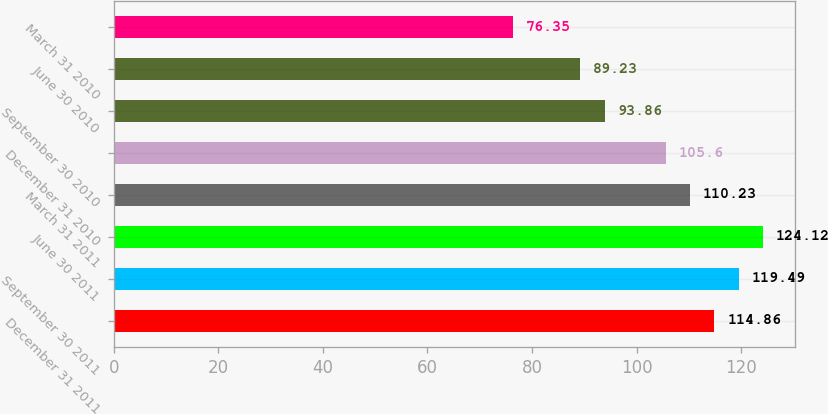Convert chart. <chart><loc_0><loc_0><loc_500><loc_500><bar_chart><fcel>December 31 2011<fcel>September 30 2011<fcel>June 30 2011<fcel>March 31 2011<fcel>December 31 2010<fcel>September 30 2010<fcel>June 30 2010<fcel>March 31 2010<nl><fcel>114.86<fcel>119.49<fcel>124.12<fcel>110.23<fcel>105.6<fcel>93.86<fcel>89.23<fcel>76.35<nl></chart> 